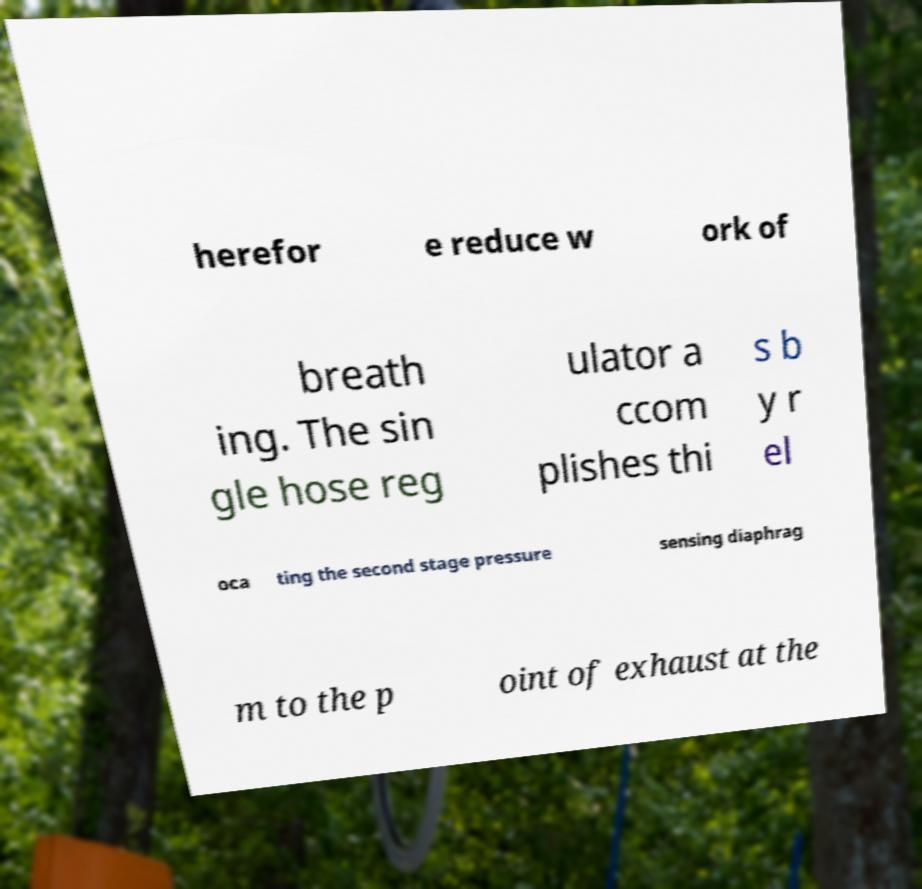Can you accurately transcribe the text from the provided image for me? herefor e reduce w ork of breath ing. The sin gle hose reg ulator a ccom plishes thi s b y r el oca ting the second stage pressure sensing diaphrag m to the p oint of exhaust at the 